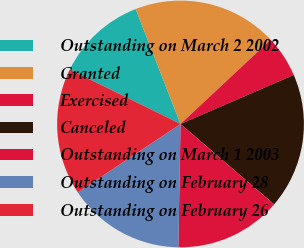<chart> <loc_0><loc_0><loc_500><loc_500><pie_chart><fcel>Outstanding on March 2 2002<fcel>Granted<fcel>Exercised<fcel>Canceled<fcel>Outstanding on March 1 2003<fcel>Outstanding on February 28<fcel>Outstanding on February 26<nl><fcel>11.8%<fcel>18.96%<fcel>5.46%<fcel>17.79%<fcel>13.99%<fcel>15.37%<fcel>16.62%<nl></chart> 